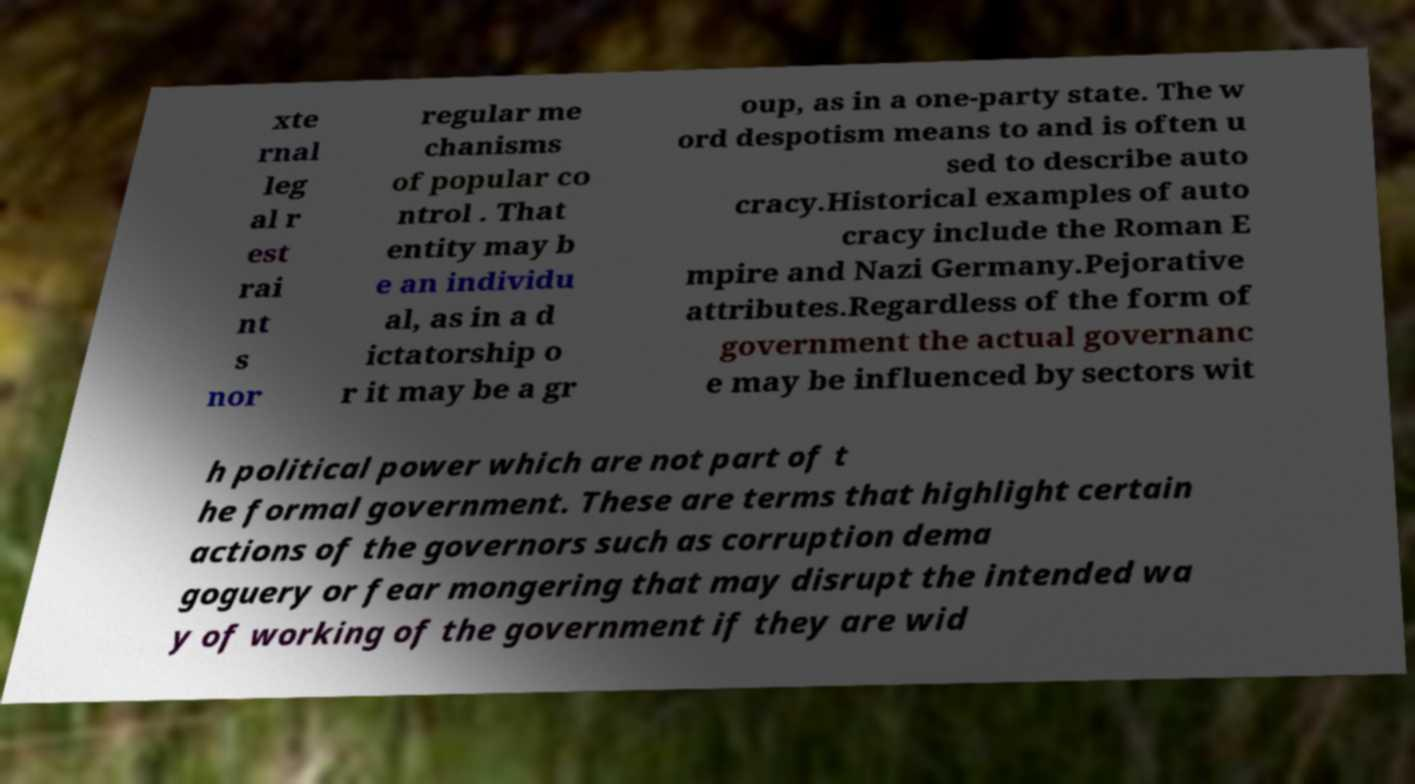Could you assist in decoding the text presented in this image and type it out clearly? xte rnal leg al r est rai nt s nor regular me chanisms of popular co ntrol . That entity may b e an individu al, as in a d ictatorship o r it may be a gr oup, as in a one-party state. The w ord despotism means to and is often u sed to describe auto cracy.Historical examples of auto cracy include the Roman E mpire and Nazi Germany.Pejorative attributes.Regardless of the form of government the actual governanc e may be influenced by sectors wit h political power which are not part of t he formal government. These are terms that highlight certain actions of the governors such as corruption dema goguery or fear mongering that may disrupt the intended wa y of working of the government if they are wid 